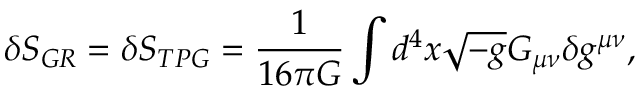Convert formula to latex. <formula><loc_0><loc_0><loc_500><loc_500>\delta S _ { G R } = \delta S _ { T P G } = \frac { 1 } { 1 6 \pi G } \int d ^ { 4 } x \sqrt { - g } G _ { \mu \nu } \delta g ^ { \mu \nu } ,</formula> 